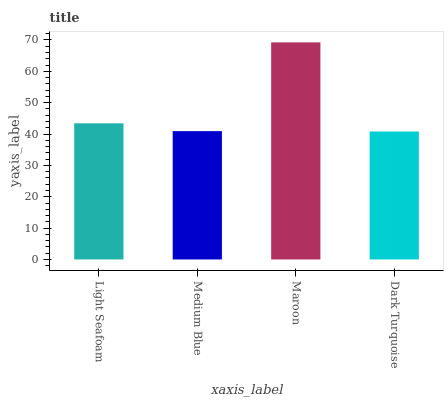Is Dark Turquoise the minimum?
Answer yes or no. Yes. Is Maroon the maximum?
Answer yes or no. Yes. Is Medium Blue the minimum?
Answer yes or no. No. Is Medium Blue the maximum?
Answer yes or no. No. Is Light Seafoam greater than Medium Blue?
Answer yes or no. Yes. Is Medium Blue less than Light Seafoam?
Answer yes or no. Yes. Is Medium Blue greater than Light Seafoam?
Answer yes or no. No. Is Light Seafoam less than Medium Blue?
Answer yes or no. No. Is Light Seafoam the high median?
Answer yes or no. Yes. Is Medium Blue the low median?
Answer yes or no. Yes. Is Dark Turquoise the high median?
Answer yes or no. No. Is Light Seafoam the low median?
Answer yes or no. No. 